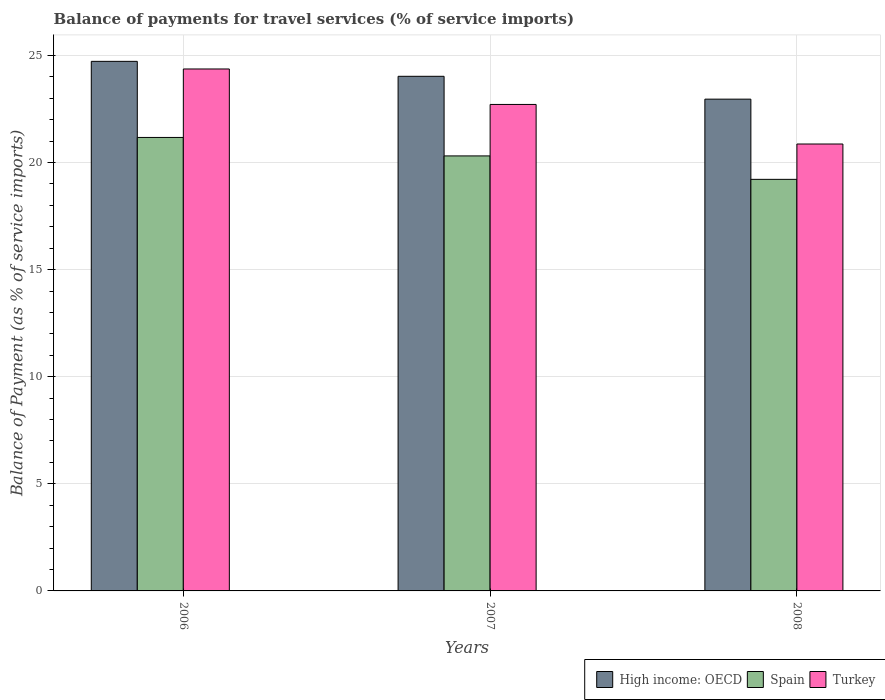How many groups of bars are there?
Ensure brevity in your answer.  3. How many bars are there on the 1st tick from the left?
Your answer should be very brief. 3. In how many cases, is the number of bars for a given year not equal to the number of legend labels?
Make the answer very short. 0. What is the balance of payments for travel services in High income: OECD in 2008?
Your answer should be very brief. 22.96. Across all years, what is the maximum balance of payments for travel services in High income: OECD?
Make the answer very short. 24.72. Across all years, what is the minimum balance of payments for travel services in Turkey?
Keep it short and to the point. 20.86. In which year was the balance of payments for travel services in High income: OECD minimum?
Your answer should be very brief. 2008. What is the total balance of payments for travel services in High income: OECD in the graph?
Provide a short and direct response. 71.7. What is the difference between the balance of payments for travel services in Turkey in 2007 and that in 2008?
Your answer should be very brief. 1.85. What is the difference between the balance of payments for travel services in High income: OECD in 2008 and the balance of payments for travel services in Spain in 2006?
Provide a succinct answer. 1.79. What is the average balance of payments for travel services in Turkey per year?
Ensure brevity in your answer.  22.64. In the year 2007, what is the difference between the balance of payments for travel services in High income: OECD and balance of payments for travel services in Turkey?
Ensure brevity in your answer.  1.31. What is the ratio of the balance of payments for travel services in High income: OECD in 2007 to that in 2008?
Keep it short and to the point. 1.05. Is the balance of payments for travel services in Spain in 2006 less than that in 2008?
Give a very brief answer. No. Is the difference between the balance of payments for travel services in High income: OECD in 2006 and 2007 greater than the difference between the balance of payments for travel services in Turkey in 2006 and 2007?
Make the answer very short. No. What is the difference between the highest and the second highest balance of payments for travel services in High income: OECD?
Give a very brief answer. 0.7. What is the difference between the highest and the lowest balance of payments for travel services in Spain?
Offer a terse response. 1.96. Is it the case that in every year, the sum of the balance of payments for travel services in Turkey and balance of payments for travel services in High income: OECD is greater than the balance of payments for travel services in Spain?
Give a very brief answer. Yes. How many bars are there?
Offer a very short reply. 9. How many years are there in the graph?
Make the answer very short. 3. Are the values on the major ticks of Y-axis written in scientific E-notation?
Provide a short and direct response. No. Does the graph contain grids?
Offer a terse response. Yes. Where does the legend appear in the graph?
Ensure brevity in your answer.  Bottom right. How are the legend labels stacked?
Make the answer very short. Horizontal. What is the title of the graph?
Provide a short and direct response. Balance of payments for travel services (% of service imports). Does "Cyprus" appear as one of the legend labels in the graph?
Offer a terse response. No. What is the label or title of the Y-axis?
Provide a short and direct response. Balance of Payment (as % of service imports). What is the Balance of Payment (as % of service imports) of High income: OECD in 2006?
Make the answer very short. 24.72. What is the Balance of Payment (as % of service imports) of Spain in 2006?
Make the answer very short. 21.17. What is the Balance of Payment (as % of service imports) of Turkey in 2006?
Offer a very short reply. 24.36. What is the Balance of Payment (as % of service imports) in High income: OECD in 2007?
Offer a very short reply. 24.02. What is the Balance of Payment (as % of service imports) in Spain in 2007?
Make the answer very short. 20.31. What is the Balance of Payment (as % of service imports) of Turkey in 2007?
Your response must be concise. 22.71. What is the Balance of Payment (as % of service imports) in High income: OECD in 2008?
Your answer should be very brief. 22.96. What is the Balance of Payment (as % of service imports) of Spain in 2008?
Provide a short and direct response. 19.21. What is the Balance of Payment (as % of service imports) in Turkey in 2008?
Provide a succinct answer. 20.86. Across all years, what is the maximum Balance of Payment (as % of service imports) in High income: OECD?
Offer a very short reply. 24.72. Across all years, what is the maximum Balance of Payment (as % of service imports) of Spain?
Provide a succinct answer. 21.17. Across all years, what is the maximum Balance of Payment (as % of service imports) in Turkey?
Your answer should be compact. 24.36. Across all years, what is the minimum Balance of Payment (as % of service imports) in High income: OECD?
Your answer should be compact. 22.96. Across all years, what is the minimum Balance of Payment (as % of service imports) of Spain?
Your answer should be very brief. 19.21. Across all years, what is the minimum Balance of Payment (as % of service imports) of Turkey?
Make the answer very short. 20.86. What is the total Balance of Payment (as % of service imports) in High income: OECD in the graph?
Your response must be concise. 71.7. What is the total Balance of Payment (as % of service imports) in Spain in the graph?
Give a very brief answer. 60.69. What is the total Balance of Payment (as % of service imports) of Turkey in the graph?
Keep it short and to the point. 67.93. What is the difference between the Balance of Payment (as % of service imports) of High income: OECD in 2006 and that in 2007?
Provide a succinct answer. 0.7. What is the difference between the Balance of Payment (as % of service imports) in Spain in 2006 and that in 2007?
Your answer should be compact. 0.86. What is the difference between the Balance of Payment (as % of service imports) of Turkey in 2006 and that in 2007?
Provide a succinct answer. 1.66. What is the difference between the Balance of Payment (as % of service imports) in High income: OECD in 2006 and that in 2008?
Give a very brief answer. 1.76. What is the difference between the Balance of Payment (as % of service imports) of Spain in 2006 and that in 2008?
Give a very brief answer. 1.96. What is the difference between the Balance of Payment (as % of service imports) of Turkey in 2006 and that in 2008?
Offer a very short reply. 3.5. What is the difference between the Balance of Payment (as % of service imports) of High income: OECD in 2007 and that in 2008?
Give a very brief answer. 1.07. What is the difference between the Balance of Payment (as % of service imports) of Spain in 2007 and that in 2008?
Ensure brevity in your answer.  1.09. What is the difference between the Balance of Payment (as % of service imports) in Turkey in 2007 and that in 2008?
Offer a terse response. 1.85. What is the difference between the Balance of Payment (as % of service imports) in High income: OECD in 2006 and the Balance of Payment (as % of service imports) in Spain in 2007?
Keep it short and to the point. 4.41. What is the difference between the Balance of Payment (as % of service imports) of High income: OECD in 2006 and the Balance of Payment (as % of service imports) of Turkey in 2007?
Offer a very short reply. 2.01. What is the difference between the Balance of Payment (as % of service imports) of Spain in 2006 and the Balance of Payment (as % of service imports) of Turkey in 2007?
Your response must be concise. -1.54. What is the difference between the Balance of Payment (as % of service imports) in High income: OECD in 2006 and the Balance of Payment (as % of service imports) in Spain in 2008?
Your answer should be very brief. 5.51. What is the difference between the Balance of Payment (as % of service imports) of High income: OECD in 2006 and the Balance of Payment (as % of service imports) of Turkey in 2008?
Provide a succinct answer. 3.86. What is the difference between the Balance of Payment (as % of service imports) of Spain in 2006 and the Balance of Payment (as % of service imports) of Turkey in 2008?
Provide a short and direct response. 0.31. What is the difference between the Balance of Payment (as % of service imports) in High income: OECD in 2007 and the Balance of Payment (as % of service imports) in Spain in 2008?
Offer a terse response. 4.81. What is the difference between the Balance of Payment (as % of service imports) of High income: OECD in 2007 and the Balance of Payment (as % of service imports) of Turkey in 2008?
Your answer should be compact. 3.16. What is the difference between the Balance of Payment (as % of service imports) in Spain in 2007 and the Balance of Payment (as % of service imports) in Turkey in 2008?
Your answer should be compact. -0.56. What is the average Balance of Payment (as % of service imports) of High income: OECD per year?
Your response must be concise. 23.9. What is the average Balance of Payment (as % of service imports) of Spain per year?
Your answer should be compact. 20.23. What is the average Balance of Payment (as % of service imports) of Turkey per year?
Offer a very short reply. 22.64. In the year 2006, what is the difference between the Balance of Payment (as % of service imports) in High income: OECD and Balance of Payment (as % of service imports) in Spain?
Provide a short and direct response. 3.55. In the year 2006, what is the difference between the Balance of Payment (as % of service imports) in High income: OECD and Balance of Payment (as % of service imports) in Turkey?
Keep it short and to the point. 0.36. In the year 2006, what is the difference between the Balance of Payment (as % of service imports) in Spain and Balance of Payment (as % of service imports) in Turkey?
Your response must be concise. -3.2. In the year 2007, what is the difference between the Balance of Payment (as % of service imports) of High income: OECD and Balance of Payment (as % of service imports) of Spain?
Ensure brevity in your answer.  3.72. In the year 2007, what is the difference between the Balance of Payment (as % of service imports) in High income: OECD and Balance of Payment (as % of service imports) in Turkey?
Make the answer very short. 1.31. In the year 2007, what is the difference between the Balance of Payment (as % of service imports) of Spain and Balance of Payment (as % of service imports) of Turkey?
Your answer should be compact. -2.4. In the year 2008, what is the difference between the Balance of Payment (as % of service imports) in High income: OECD and Balance of Payment (as % of service imports) in Spain?
Make the answer very short. 3.74. In the year 2008, what is the difference between the Balance of Payment (as % of service imports) of High income: OECD and Balance of Payment (as % of service imports) of Turkey?
Give a very brief answer. 2.09. In the year 2008, what is the difference between the Balance of Payment (as % of service imports) of Spain and Balance of Payment (as % of service imports) of Turkey?
Make the answer very short. -1.65. What is the ratio of the Balance of Payment (as % of service imports) in High income: OECD in 2006 to that in 2007?
Offer a terse response. 1.03. What is the ratio of the Balance of Payment (as % of service imports) in Spain in 2006 to that in 2007?
Provide a short and direct response. 1.04. What is the ratio of the Balance of Payment (as % of service imports) of Turkey in 2006 to that in 2007?
Your answer should be very brief. 1.07. What is the ratio of the Balance of Payment (as % of service imports) of High income: OECD in 2006 to that in 2008?
Keep it short and to the point. 1.08. What is the ratio of the Balance of Payment (as % of service imports) of Spain in 2006 to that in 2008?
Offer a very short reply. 1.1. What is the ratio of the Balance of Payment (as % of service imports) in Turkey in 2006 to that in 2008?
Your response must be concise. 1.17. What is the ratio of the Balance of Payment (as % of service imports) of High income: OECD in 2007 to that in 2008?
Keep it short and to the point. 1.05. What is the ratio of the Balance of Payment (as % of service imports) of Spain in 2007 to that in 2008?
Provide a short and direct response. 1.06. What is the ratio of the Balance of Payment (as % of service imports) of Turkey in 2007 to that in 2008?
Keep it short and to the point. 1.09. What is the difference between the highest and the second highest Balance of Payment (as % of service imports) of High income: OECD?
Your response must be concise. 0.7. What is the difference between the highest and the second highest Balance of Payment (as % of service imports) in Spain?
Your answer should be very brief. 0.86. What is the difference between the highest and the second highest Balance of Payment (as % of service imports) of Turkey?
Your answer should be compact. 1.66. What is the difference between the highest and the lowest Balance of Payment (as % of service imports) of High income: OECD?
Make the answer very short. 1.76. What is the difference between the highest and the lowest Balance of Payment (as % of service imports) of Spain?
Offer a terse response. 1.96. What is the difference between the highest and the lowest Balance of Payment (as % of service imports) of Turkey?
Your response must be concise. 3.5. 